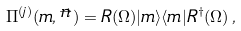Convert formula to latex. <formula><loc_0><loc_0><loc_500><loc_500>\Pi ^ { ( j ) } ( m , \stackrel { \rightarrow } { n } ) = R ( \Omega ) | m \rangle \langle m | R ^ { \dag } ( \Omega ) \, ,</formula> 